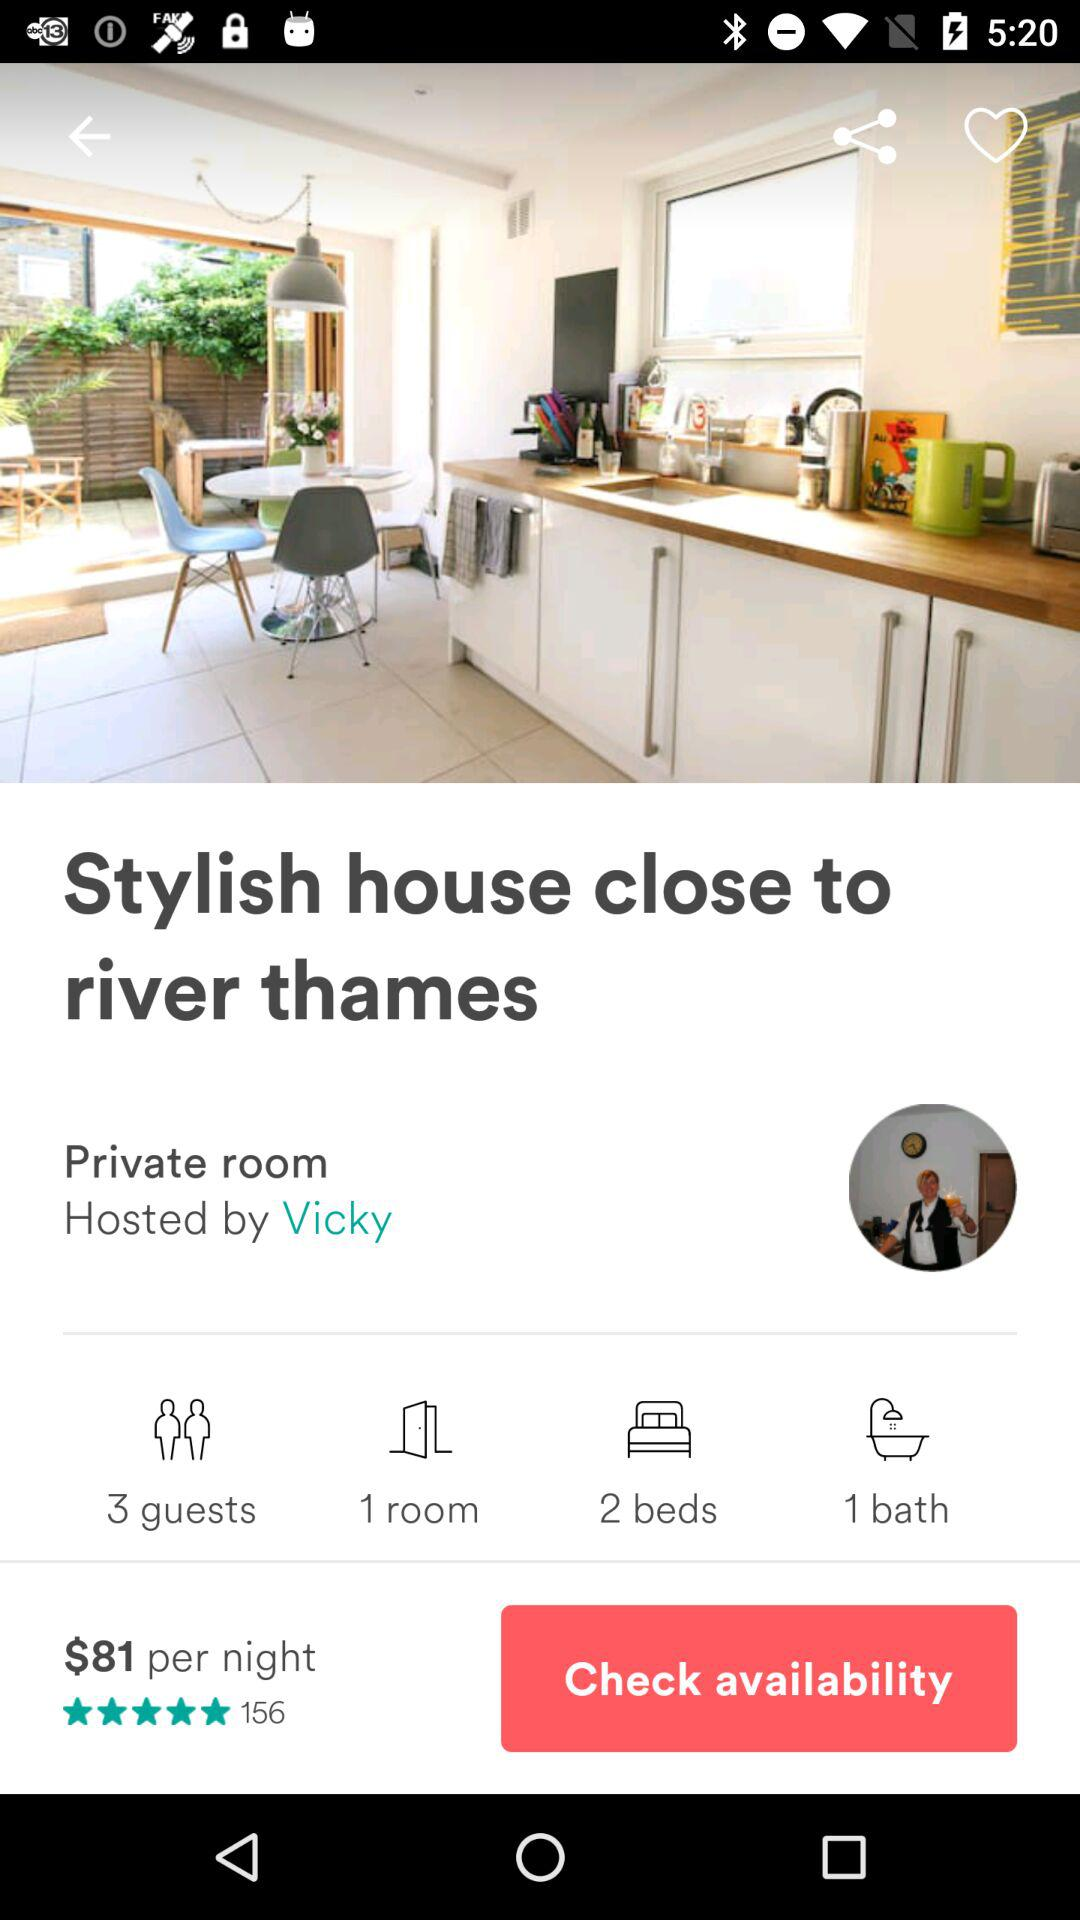Which dates are selected for check-in and check-out?
When the provided information is insufficient, respond with <no answer>. <no answer> 